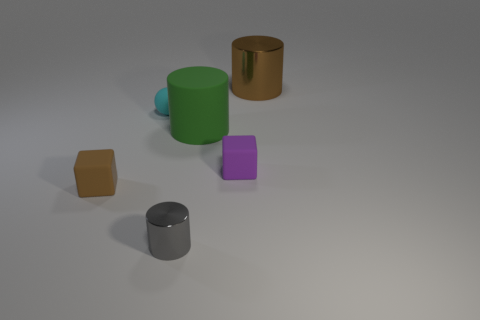What size is the metallic thing that is in front of the green cylinder that is on the left side of the cylinder that is right of the purple matte object?
Give a very brief answer. Small. What is the shape of the cyan rubber object?
Offer a terse response. Sphere. There is a brown object behind the purple rubber block; how many tiny brown matte objects are in front of it?
Your response must be concise. 1. What number of other objects are the same material as the small gray cylinder?
Your answer should be very brief. 1. Does the cube that is in front of the purple rubber block have the same material as the cube to the right of the green rubber object?
Offer a terse response. Yes. Are there any other things that have the same shape as the tiny cyan object?
Give a very brief answer. No. Does the purple block have the same material as the cylinder that is behind the cyan rubber sphere?
Make the answer very short. No. There is a metal cylinder that is behind the big cylinder in front of the metallic thing behind the green cylinder; what is its color?
Keep it short and to the point. Brown. There is a purple object that is the same size as the brown matte object; what shape is it?
Your answer should be very brief. Cube. Does the brown matte block that is to the left of the large brown cylinder have the same size as the rubber block that is behind the tiny brown thing?
Your answer should be compact. Yes. 